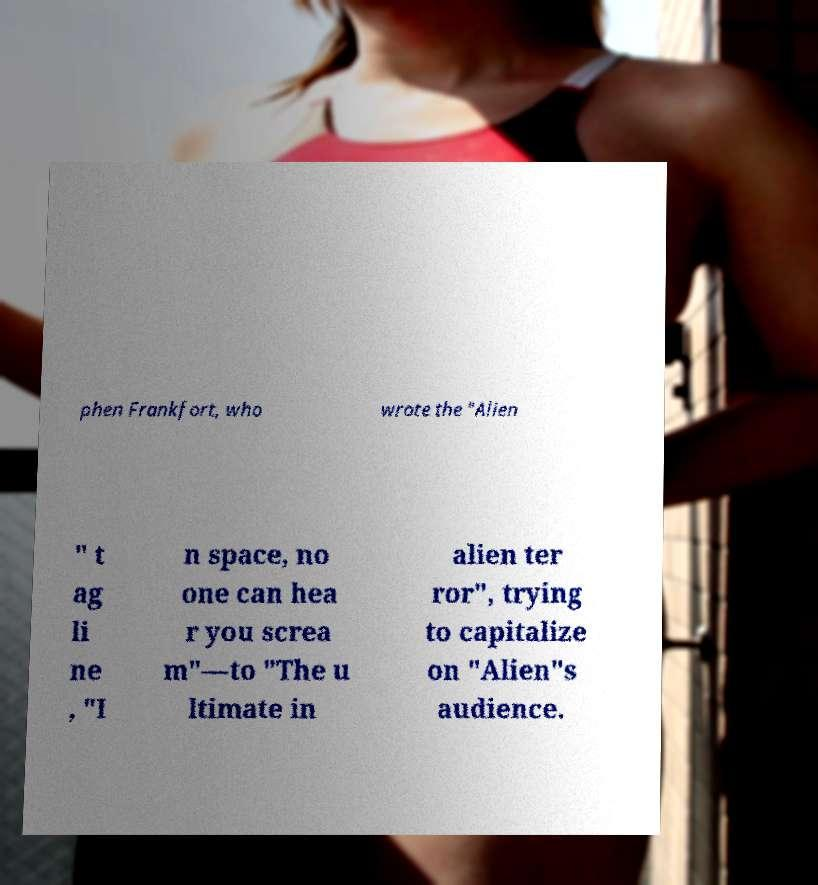Please read and relay the text visible in this image. What does it say? phen Frankfort, who wrote the "Alien " t ag li ne , "I n space, no one can hea r you screa m"—to "The u ltimate in alien ter ror", trying to capitalize on "Alien"s audience. 